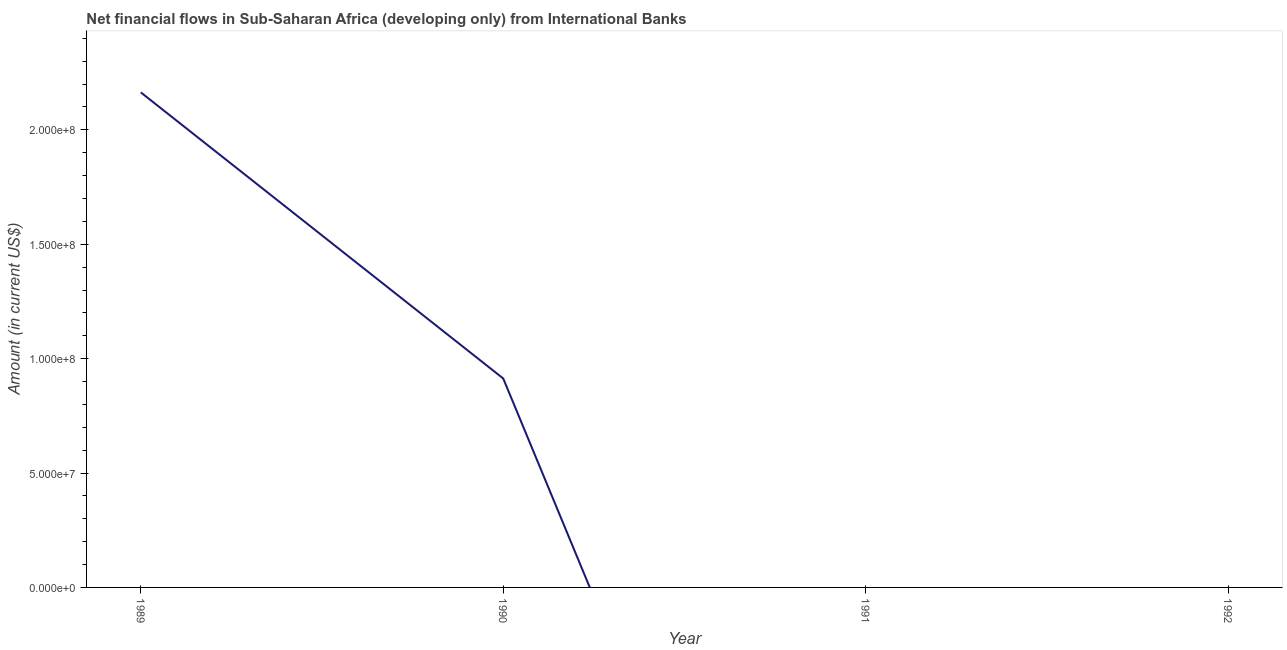Across all years, what is the maximum net financial flows from ibrd?
Offer a very short reply. 2.16e+08. What is the sum of the net financial flows from ibrd?
Make the answer very short. 3.08e+08. What is the difference between the net financial flows from ibrd in 1989 and 1990?
Your answer should be very brief. 1.25e+08. What is the average net financial flows from ibrd per year?
Your answer should be very brief. 7.69e+07. What is the median net financial flows from ibrd?
Your answer should be compact. 4.57e+07. What is the difference between the highest and the lowest net financial flows from ibrd?
Your answer should be very brief. 2.16e+08. How many years are there in the graph?
Keep it short and to the point. 4. What is the difference between two consecutive major ticks on the Y-axis?
Ensure brevity in your answer.  5.00e+07. Does the graph contain any zero values?
Provide a succinct answer. Yes. What is the title of the graph?
Your response must be concise. Net financial flows in Sub-Saharan Africa (developing only) from International Banks. What is the label or title of the X-axis?
Provide a succinct answer. Year. What is the label or title of the Y-axis?
Make the answer very short. Amount (in current US$). What is the Amount (in current US$) of 1989?
Make the answer very short. 2.16e+08. What is the Amount (in current US$) in 1990?
Provide a succinct answer. 9.13e+07. What is the difference between the Amount (in current US$) in 1989 and 1990?
Give a very brief answer. 1.25e+08. What is the ratio of the Amount (in current US$) in 1989 to that in 1990?
Give a very brief answer. 2.37. 